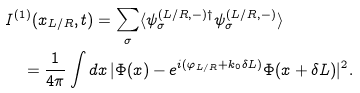Convert formula to latex. <formula><loc_0><loc_0><loc_500><loc_500>& I ^ { ( 1 ) } ( x _ { L / R } , t ) = \sum _ { \sigma } \langle \psi _ { \sigma } ^ { ( L / R , - ) \dag } \psi _ { \sigma } ^ { ( L / R , - ) } \rangle \\ & \quad = \frac { 1 } { 4 \pi } \int d x \, | \Phi ( x ) - e ^ { i ( \varphi _ { L / R } + k _ { 0 } \delta L ) } \Phi ( x + \delta L ) | ^ { 2 } .</formula> 